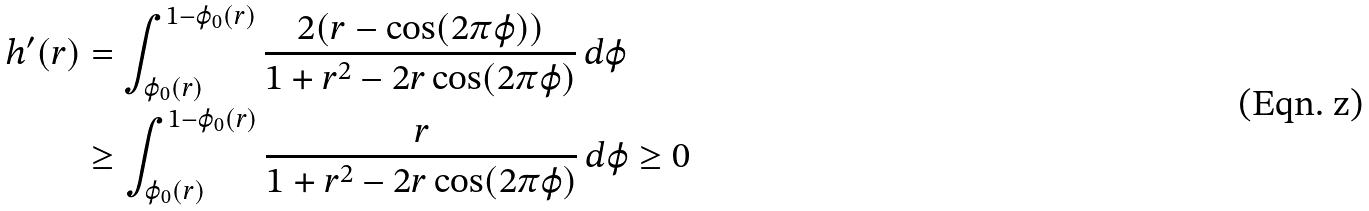<formula> <loc_0><loc_0><loc_500><loc_500>h ^ { \prime } ( r ) & = \int _ { \varphi _ { 0 } ( r ) } ^ { 1 - \varphi _ { 0 } ( r ) } \frac { 2 ( r - \cos ( 2 \pi \varphi ) ) } { 1 + r ^ { 2 } - 2 r \cos ( 2 \pi \varphi ) } \, d \varphi \\ & \geq \int _ { \varphi _ { 0 } ( r ) } ^ { 1 - \varphi _ { 0 } ( r ) } \frac { r } { 1 + r ^ { 2 } - 2 r \cos ( 2 \pi \varphi ) } \, d \varphi \geq 0</formula> 